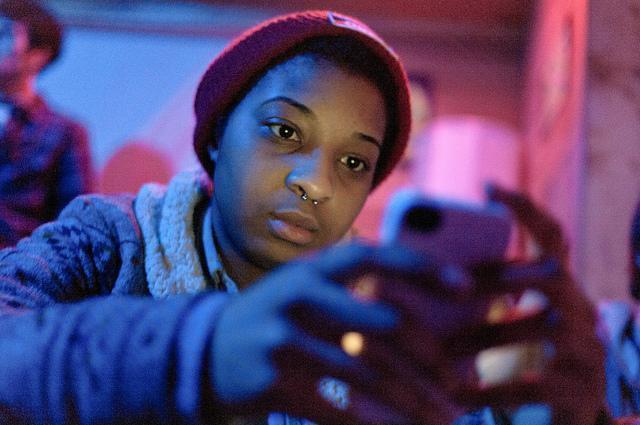What kind of media is she consuming?
Choose the right answer from the provided options to respond to the question.
Options: Television, film, digital, print. Digital. 